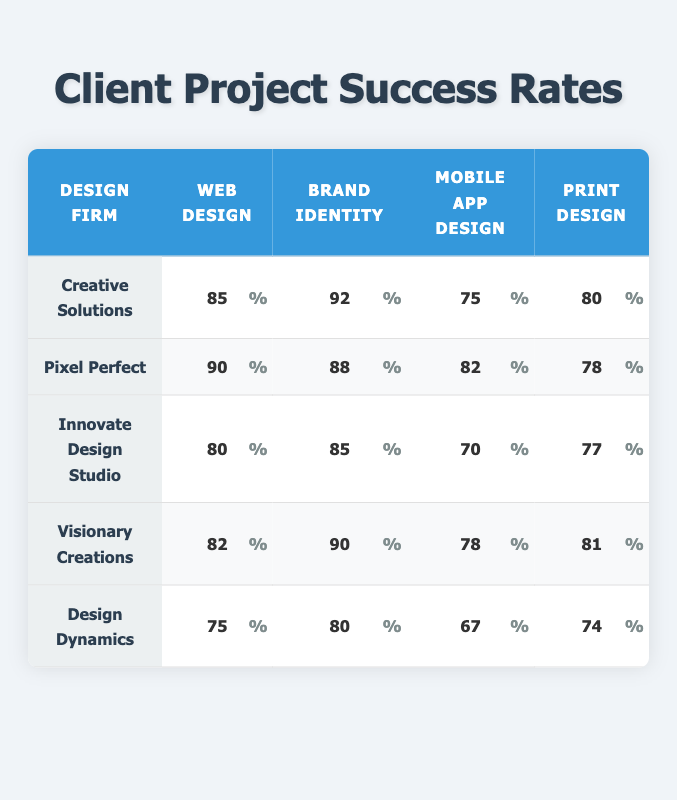What is the success rate of Creative Solutions in Brand Identity design? The table indicates that Creative Solutions has a success rate of 92% in Brand Identity design.
Answer: 92% Which design firm has the highest success rate in Mobile App Design? By comparing the success rates in the Mobile App Design column, Pixel Perfect has the highest rate at 82%.
Answer: Pixel Perfect What is the average success rate of Visionary Creations across all project types? To find the average, sum the values for Visionary Creations: (82 + 90 + 78 + 81) = 331, then divide by 4 (the number of project types), resulting in an average of 82.75.
Answer: 82.75 Does Design Dynamics have a higher success rate in Print Design than Innovate Design Studio? Design Dynamics has a success rate of 74% in Print Design, while Innovate Design Studio has a rate of 77%. Since 74% is less than 77%, the statement is false.
Answer: No What is the difference in success rates between the best and worst performing design firm in Web Design? Web Design success rates are: Creative Solutions (85%), Pixel Perfect (90%), Innovate Design Studio (80%), Visionary Creations (82%), and Design Dynamics (75%). The best is Pixel Perfect at 90% and the worst is Design Dynamics at 75%. The difference is 90 - 75 = 15%.
Answer: 15% Which design firm performs better in Print Design, Creative Solutions or Visionary Creations? Creative Solutions has a success rate of 80% in Print Design, while Visionary Creations has a rate of 81%. Since 81% is higher than 80%, Visionary Creations performs better.
Answer: Visionary Creations What is the overall success rate of Innovate Design Studio in all project types? Innovate Design Studio's rates are 80% for Web Design, 85% for Brand Identity, 70% for Mobile App Design, and 77% for Print Design. To find the overall success rate, sum these values (80 + 85 + 70 + 77 = 312) and divide by 4 for the average: 312 / 4 = 78.
Answer: 78 Which project type has the lowest success rate for Design Dynamics? The success rates for Design Dynamics are 75% (Web Design), 80% (Brand Identity), 67% (Mobile App Design), and 74% (Print Design). The lowest value is 67% in Mobile App Design.
Answer: Mobile App Design Is it true that all project types performed better for Creative Solutions compared to Design Dynamics? Creative Solutions has rates of 85% (Web Design), 92% (Brand Identity), 75% (Mobile App Design), and 80% (Print Design). Design Dynamics has 75% (Web Design), 80% (Brand Identity), 67% (Mobile App Design), and 74% (Print Design). Since Design Dynamics has a lower success rate in Mobile App Design, the statement is false.
Answer: No 